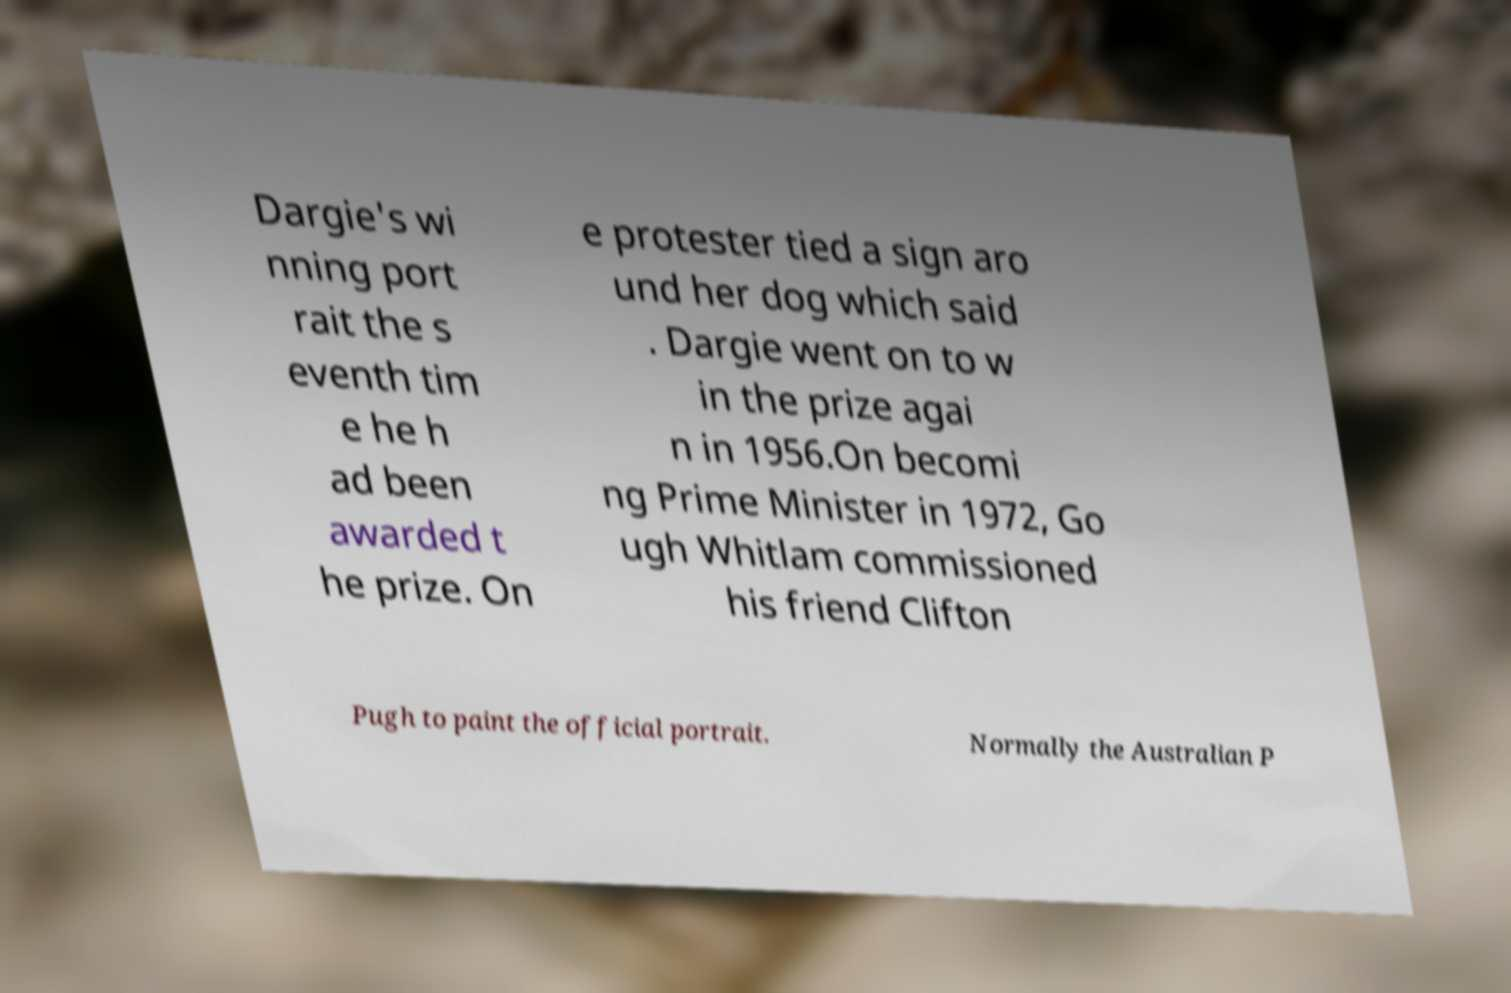Can you read and provide the text displayed in the image?This photo seems to have some interesting text. Can you extract and type it out for me? Dargie's wi nning port rait the s eventh tim e he h ad been awarded t he prize. On e protester tied a sign aro und her dog which said . Dargie went on to w in the prize agai n in 1956.On becomi ng Prime Minister in 1972, Go ugh Whitlam commissioned his friend Clifton Pugh to paint the official portrait. Normally the Australian P 